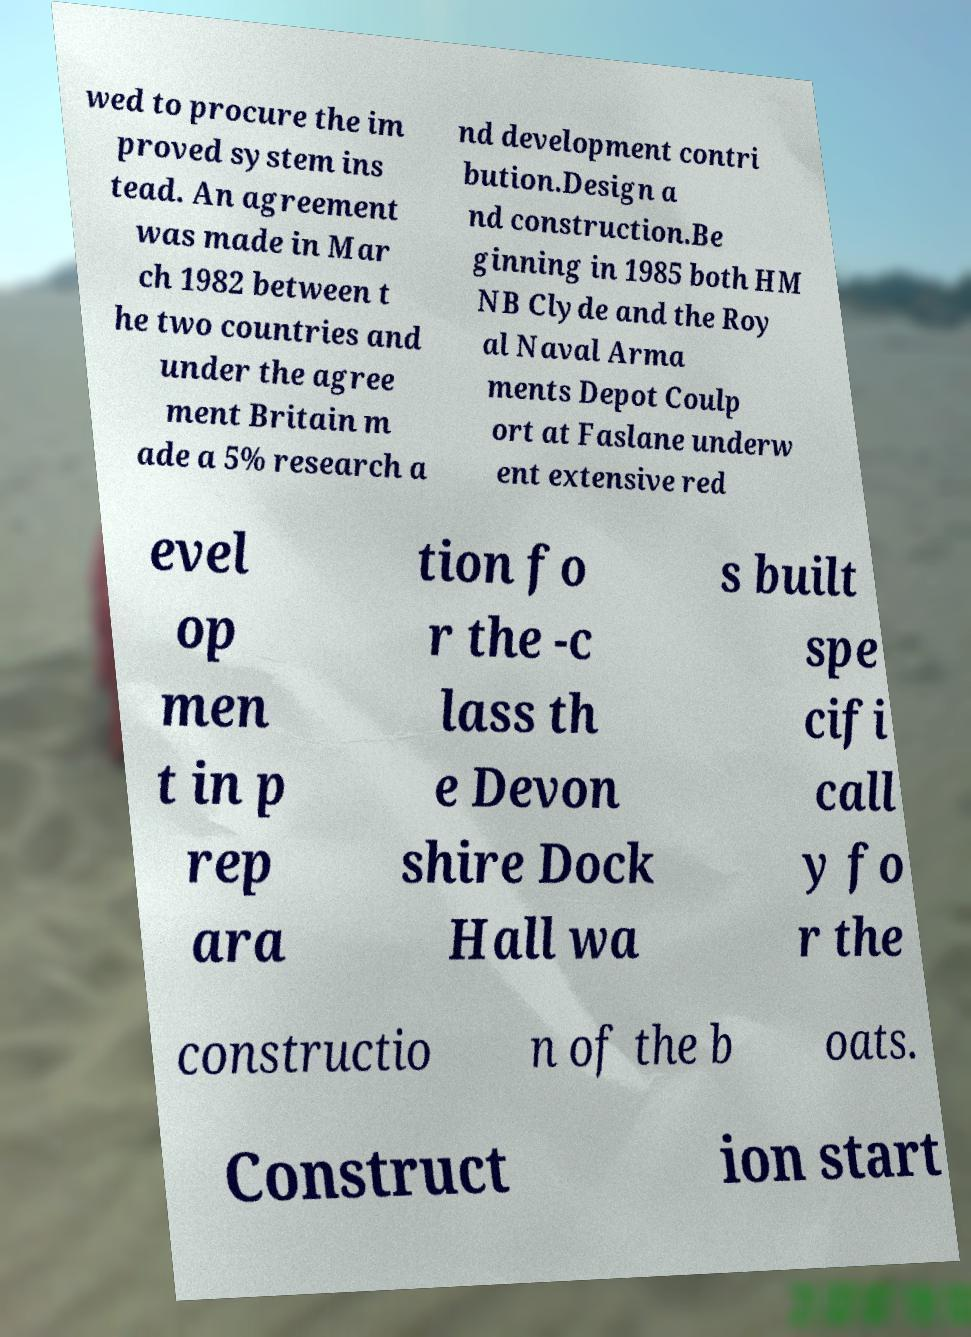There's text embedded in this image that I need extracted. Can you transcribe it verbatim? wed to procure the im proved system ins tead. An agreement was made in Mar ch 1982 between t he two countries and under the agree ment Britain m ade a 5% research a nd development contri bution.Design a nd construction.Be ginning in 1985 both HM NB Clyde and the Roy al Naval Arma ments Depot Coulp ort at Faslane underw ent extensive red evel op men t in p rep ara tion fo r the -c lass th e Devon shire Dock Hall wa s built spe cifi call y fo r the constructio n of the b oats. Construct ion start 